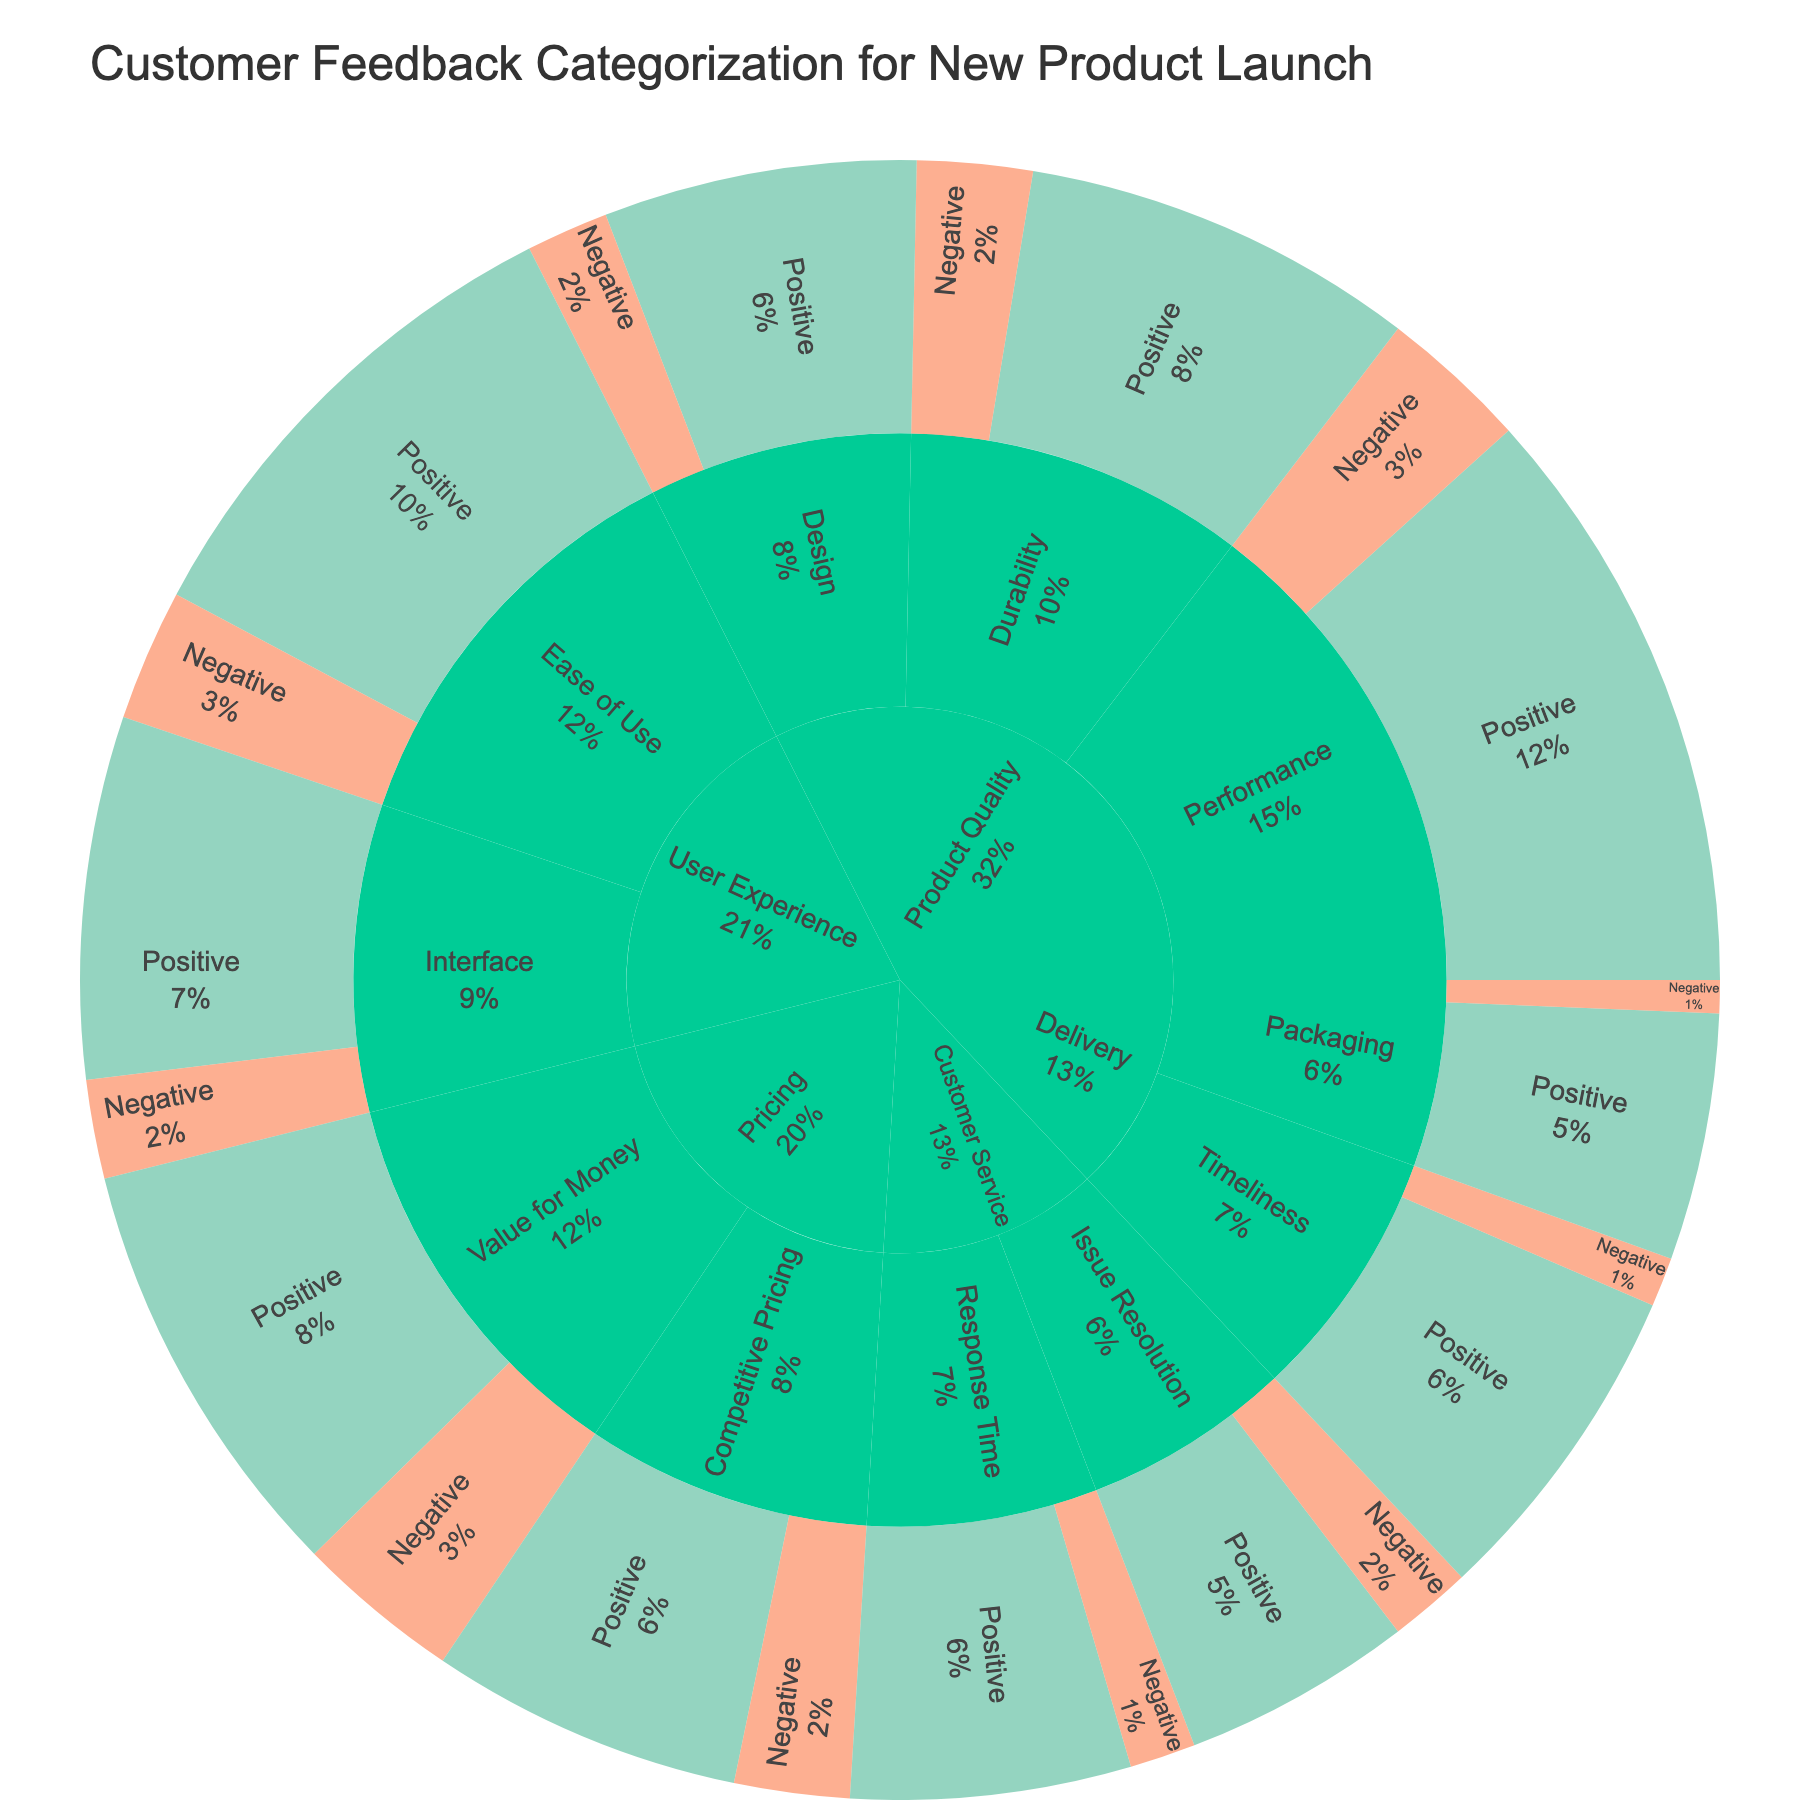What is the title of the Sunburst Plot? The title is found at the top of the plot, clearly indicating the focus of the visualization.
Answer: Customer Feedback Categorization for New Product Launch How many categories are displayed in the Sunburst Plot? Count the outermost segments representing the highest level of categorization.
Answer: 5 Which subcategory under 'Product Quality' has the highest number of positive feedback? Look at the segments within 'Product Quality' and compare the sizes or values displayed for positive feedback.
Answer: Performance What is the total count of negative feedback for 'User Experience'? Sum the counts of all the negative feedback types under 'User Experience'.
Answer: 70 Which category has more positive feedback, 'Customer Service' or 'Delivery'? Compare the sizes or values of the positive feedback segments between 'Customer Service' and 'Delivery'.
Answer: Delivery How many subcategories are there under 'Pricing'? Count the distinct subcategories within the 'Pricing' category.
Answer: 2 What percentage of all feedback is negative for 'Competitive Pricing'? Find the segment for 'Competitive Pricing' negative feedback and note the percentage shown or calculate based on total feedback.
Answer: Needs specific figure, but the count is 35 out of a total of 595 Which has greater negative feedback in the subcategory, 'Ease of Use' or 'Interface'? Compare the negative feedback segments within 'Ease of Use' and 'Interface'.
Answer: Ease of Use What is the sum of all positive feedback across categories? Add the counts of all positive feedback segments.
Answer: 1310 Which feedback type for 'Timeliness' is less frequent, positive or negative? Compare the counts or sizes of the positive and negative feedback segments within 'Timeliness’.
Answer: Negative 